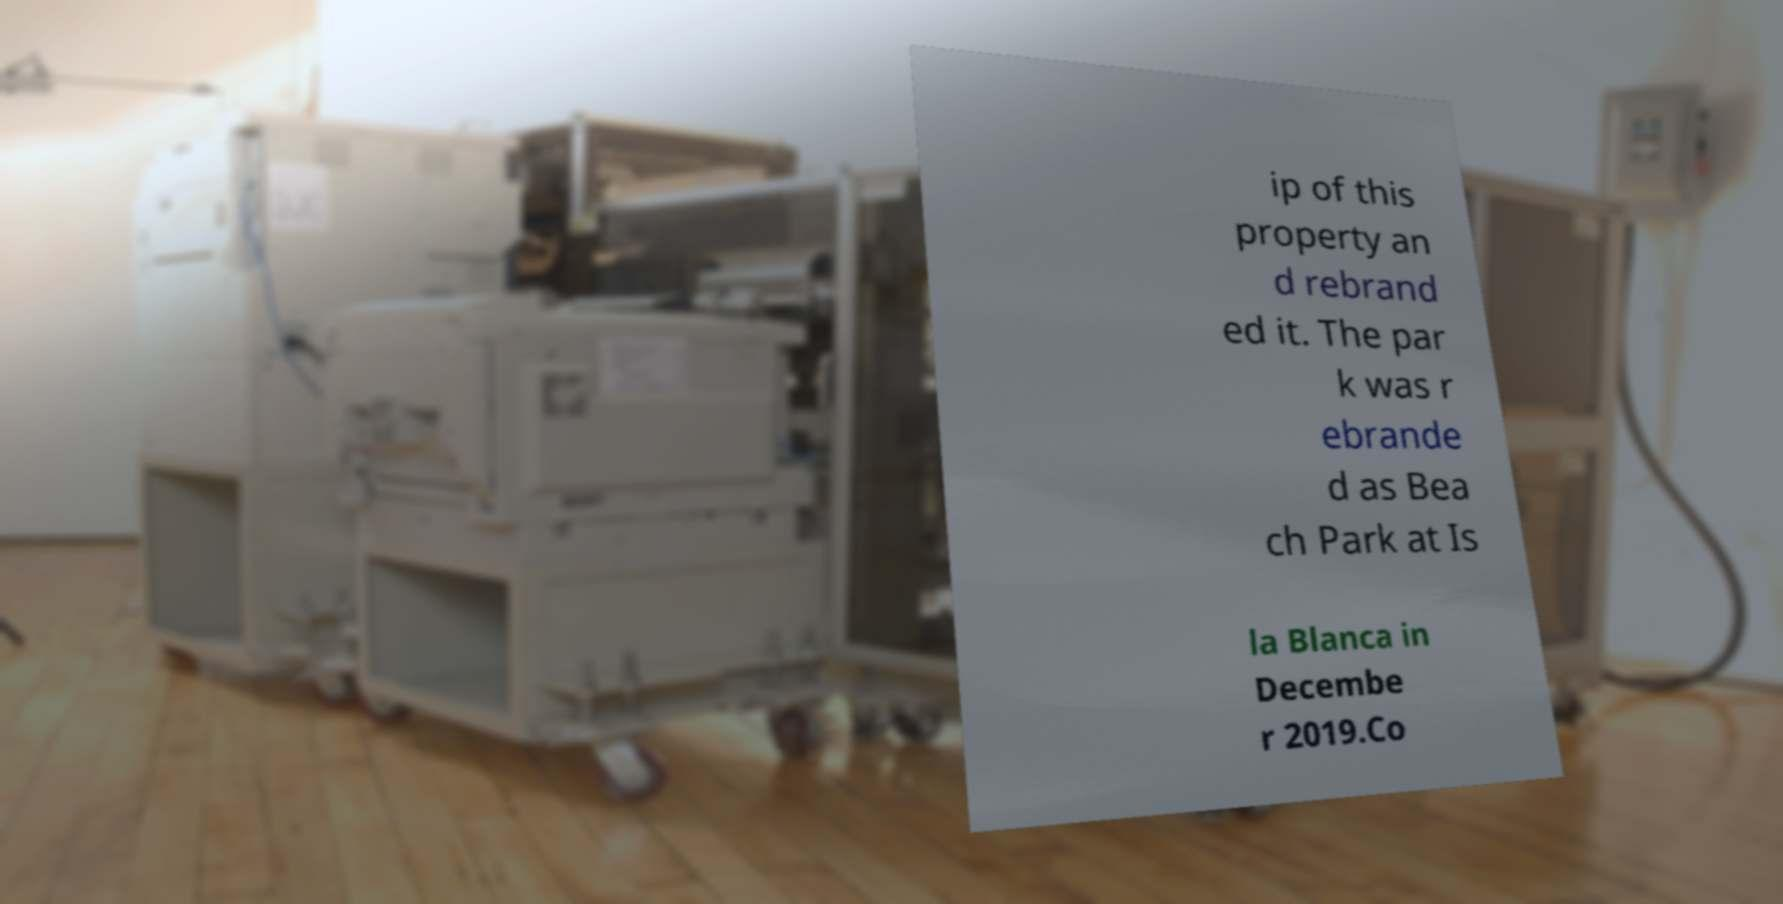What messages or text are displayed in this image? I need them in a readable, typed format. ip of this property an d rebrand ed it. The par k was r ebrande d as Bea ch Park at Is la Blanca in Decembe r 2019.Co 